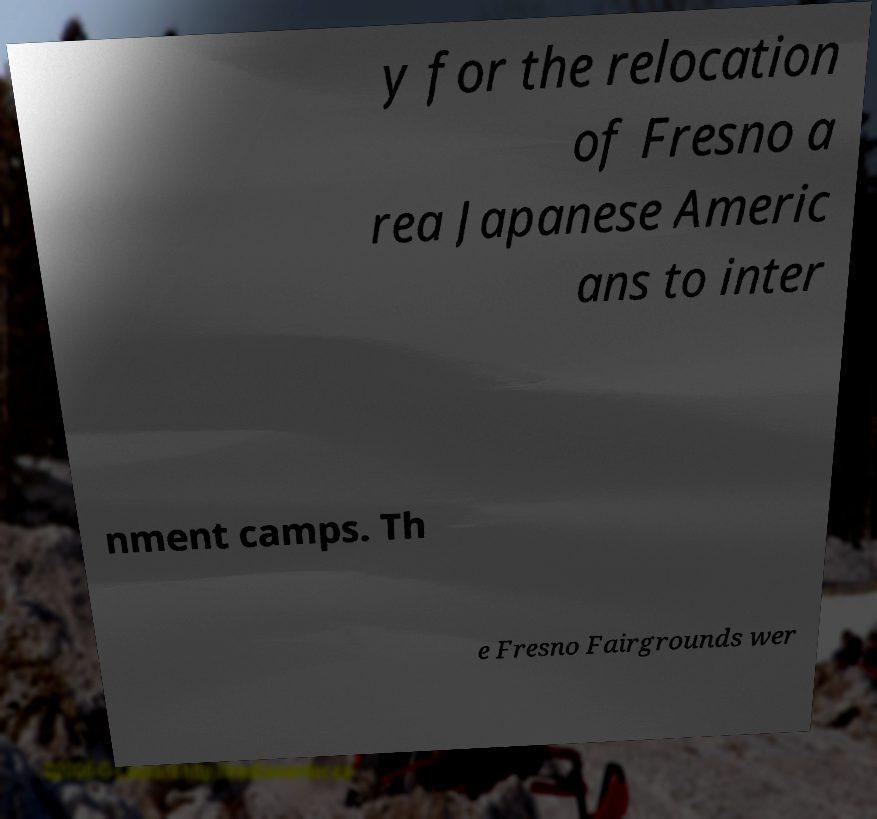There's text embedded in this image that I need extracted. Can you transcribe it verbatim? y for the relocation of Fresno a rea Japanese Americ ans to inter nment camps. Th e Fresno Fairgrounds wer 